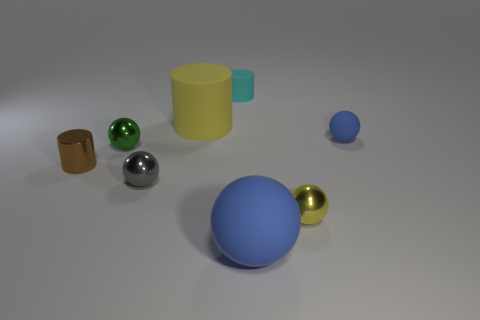Subtract all large matte balls. How many balls are left? 4 Add 2 gray spheres. How many objects exist? 10 Subtract all cyan cylinders. How many cylinders are left? 2 Subtract 2 balls. How many balls are left? 3 Subtract all cylinders. How many objects are left? 5 Subtract all yellow cylinders. Subtract all yellow blocks. How many cylinders are left? 2 Subtract all gray spheres. How many purple cylinders are left? 0 Subtract all brown rubber cylinders. Subtract all blue objects. How many objects are left? 6 Add 1 green balls. How many green balls are left? 2 Add 2 big gray blocks. How many big gray blocks exist? 2 